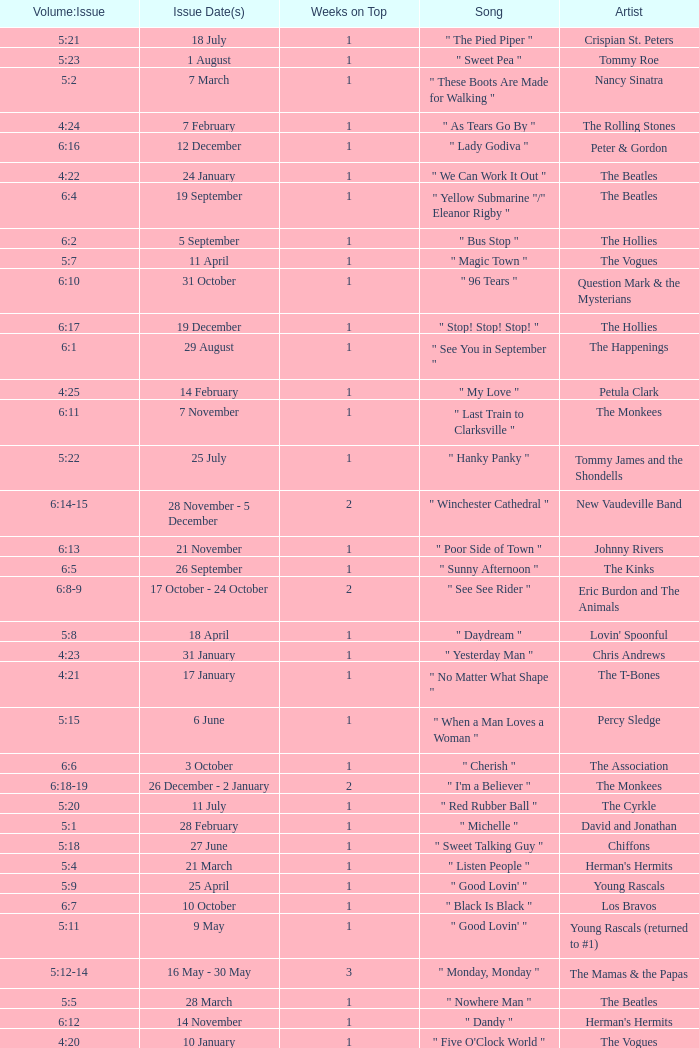With an issue date(s) of 12 September, what is in the column for Weeks on Top? 1.0. 